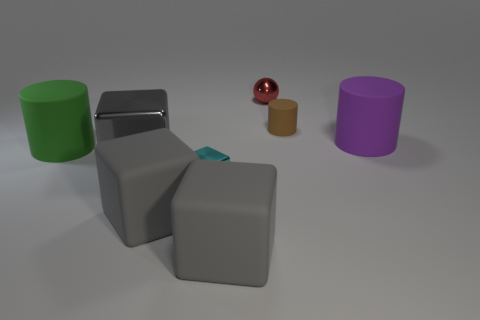Are there an equal number of small cyan blocks in front of the tiny cube and small rubber things?
Provide a succinct answer. No. There is a tiny matte object; are there any small brown matte cylinders behind it?
Ensure brevity in your answer.  No. There is a metal thing that is behind the large matte cylinder on the left side of the matte object that is right of the brown matte cylinder; how big is it?
Provide a succinct answer. Small. Does the big thing on the right side of the small red object have the same shape as the big gray thing to the right of the tiny block?
Offer a very short reply. No. What size is the cyan metal thing that is the same shape as the gray metallic object?
Give a very brief answer. Small. What number of large cubes have the same material as the tiny brown thing?
Provide a succinct answer. 2. What is the material of the small cylinder?
Give a very brief answer. Rubber. What is the shape of the large object to the right of the matte thing that is behind the large purple matte object?
Keep it short and to the point. Cylinder. What shape is the small metallic object that is in front of the small brown thing?
Keep it short and to the point. Cube. How many large cylinders are the same color as the tiny cylinder?
Offer a very short reply. 0. 